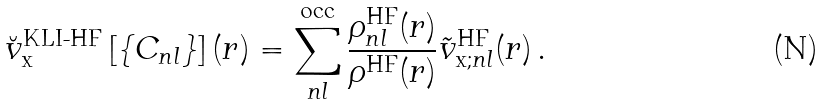Convert formula to latex. <formula><loc_0><loc_0><loc_500><loc_500>\breve { v } _ { \text {x} } ^ { \text {KLI-HF} } \left [ \{ C _ { n l } \} \right ] ( r ) = \sum _ { n l } ^ { \text {occ} } \frac { \rho _ { n l } ^ { \text {HF} } ( r ) } { \rho ^ { \text {HF} } ( r ) } \tilde { v } _ { \text {x;} n l } ^ { \text {HF} } ( r ) \, .</formula> 